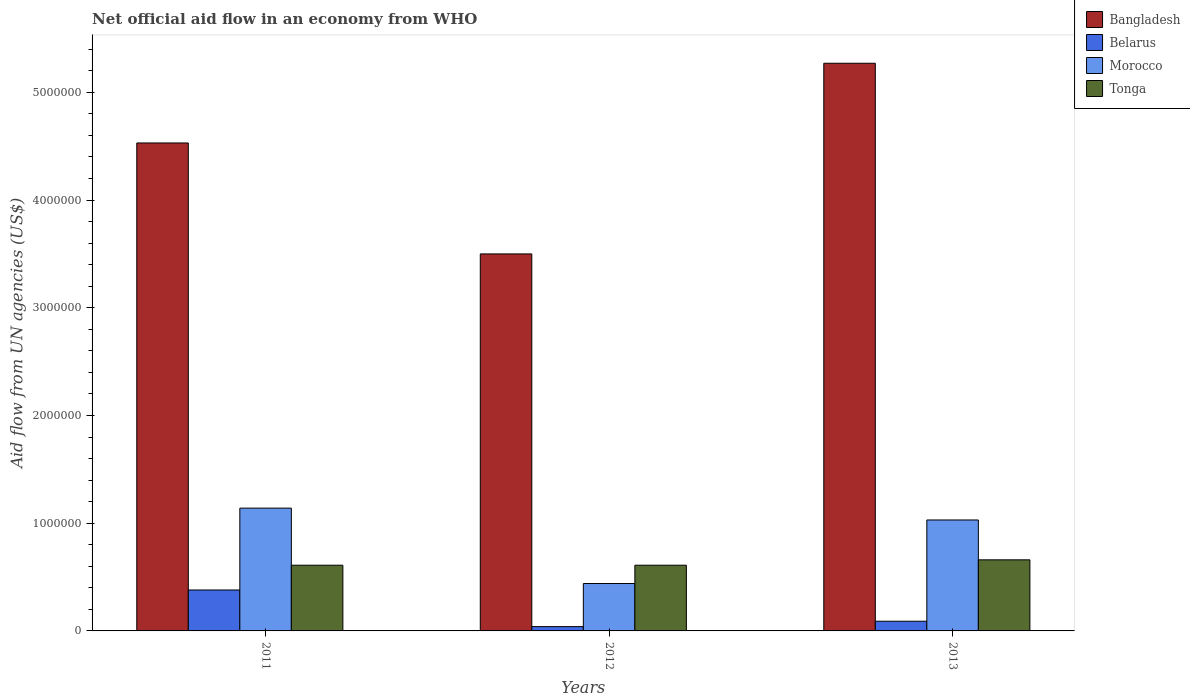Are the number of bars per tick equal to the number of legend labels?
Keep it short and to the point. Yes. How many bars are there on the 3rd tick from the left?
Your answer should be compact. 4. How many bars are there on the 2nd tick from the right?
Keep it short and to the point. 4. What is the net official aid flow in Bangladesh in 2013?
Give a very brief answer. 5.27e+06. Across all years, what is the maximum net official aid flow in Tonga?
Keep it short and to the point. 6.60e+05. What is the total net official aid flow in Bangladesh in the graph?
Give a very brief answer. 1.33e+07. What is the difference between the net official aid flow in Bangladesh in 2011 and that in 2012?
Make the answer very short. 1.03e+06. What is the difference between the net official aid flow in Tonga in 2012 and the net official aid flow in Bangladesh in 2013?
Provide a succinct answer. -4.66e+06. What is the average net official aid flow in Bangladesh per year?
Offer a terse response. 4.43e+06. In the year 2012, what is the difference between the net official aid flow in Belarus and net official aid flow in Tonga?
Ensure brevity in your answer.  -5.70e+05. What is the ratio of the net official aid flow in Morocco in 2011 to that in 2013?
Offer a terse response. 1.11. In how many years, is the net official aid flow in Belarus greater than the average net official aid flow in Belarus taken over all years?
Your response must be concise. 1. What does the 1st bar from the left in 2011 represents?
Your answer should be very brief. Bangladesh. Are all the bars in the graph horizontal?
Your answer should be very brief. No. How many years are there in the graph?
Make the answer very short. 3. What is the difference between two consecutive major ticks on the Y-axis?
Make the answer very short. 1.00e+06. Are the values on the major ticks of Y-axis written in scientific E-notation?
Your response must be concise. No. Does the graph contain grids?
Offer a very short reply. No. Where does the legend appear in the graph?
Ensure brevity in your answer.  Top right. What is the title of the graph?
Provide a succinct answer. Net official aid flow in an economy from WHO. What is the label or title of the Y-axis?
Your answer should be very brief. Aid flow from UN agencies (US$). What is the Aid flow from UN agencies (US$) of Bangladesh in 2011?
Ensure brevity in your answer.  4.53e+06. What is the Aid flow from UN agencies (US$) in Belarus in 2011?
Offer a terse response. 3.80e+05. What is the Aid flow from UN agencies (US$) of Morocco in 2011?
Give a very brief answer. 1.14e+06. What is the Aid flow from UN agencies (US$) in Bangladesh in 2012?
Your answer should be very brief. 3.50e+06. What is the Aid flow from UN agencies (US$) in Tonga in 2012?
Provide a succinct answer. 6.10e+05. What is the Aid flow from UN agencies (US$) of Bangladesh in 2013?
Give a very brief answer. 5.27e+06. What is the Aid flow from UN agencies (US$) of Belarus in 2013?
Keep it short and to the point. 9.00e+04. What is the Aid flow from UN agencies (US$) in Morocco in 2013?
Your answer should be very brief. 1.03e+06. What is the Aid flow from UN agencies (US$) of Tonga in 2013?
Your response must be concise. 6.60e+05. Across all years, what is the maximum Aid flow from UN agencies (US$) of Bangladesh?
Provide a short and direct response. 5.27e+06. Across all years, what is the maximum Aid flow from UN agencies (US$) of Belarus?
Keep it short and to the point. 3.80e+05. Across all years, what is the maximum Aid flow from UN agencies (US$) of Morocco?
Provide a succinct answer. 1.14e+06. Across all years, what is the maximum Aid flow from UN agencies (US$) of Tonga?
Provide a succinct answer. 6.60e+05. Across all years, what is the minimum Aid flow from UN agencies (US$) of Bangladesh?
Your answer should be compact. 3.50e+06. Across all years, what is the minimum Aid flow from UN agencies (US$) in Belarus?
Your answer should be very brief. 4.00e+04. Across all years, what is the minimum Aid flow from UN agencies (US$) in Morocco?
Offer a very short reply. 4.40e+05. What is the total Aid flow from UN agencies (US$) in Bangladesh in the graph?
Your response must be concise. 1.33e+07. What is the total Aid flow from UN agencies (US$) in Belarus in the graph?
Make the answer very short. 5.10e+05. What is the total Aid flow from UN agencies (US$) in Morocco in the graph?
Your response must be concise. 2.61e+06. What is the total Aid flow from UN agencies (US$) in Tonga in the graph?
Your response must be concise. 1.88e+06. What is the difference between the Aid flow from UN agencies (US$) of Bangladesh in 2011 and that in 2012?
Keep it short and to the point. 1.03e+06. What is the difference between the Aid flow from UN agencies (US$) of Morocco in 2011 and that in 2012?
Provide a succinct answer. 7.00e+05. What is the difference between the Aid flow from UN agencies (US$) of Tonga in 2011 and that in 2012?
Provide a short and direct response. 0. What is the difference between the Aid flow from UN agencies (US$) of Bangladesh in 2011 and that in 2013?
Offer a very short reply. -7.40e+05. What is the difference between the Aid flow from UN agencies (US$) of Tonga in 2011 and that in 2013?
Your answer should be compact. -5.00e+04. What is the difference between the Aid flow from UN agencies (US$) of Bangladesh in 2012 and that in 2013?
Offer a very short reply. -1.77e+06. What is the difference between the Aid flow from UN agencies (US$) of Morocco in 2012 and that in 2013?
Your answer should be very brief. -5.90e+05. What is the difference between the Aid flow from UN agencies (US$) in Tonga in 2012 and that in 2013?
Offer a very short reply. -5.00e+04. What is the difference between the Aid flow from UN agencies (US$) of Bangladesh in 2011 and the Aid flow from UN agencies (US$) of Belarus in 2012?
Provide a short and direct response. 4.49e+06. What is the difference between the Aid flow from UN agencies (US$) in Bangladesh in 2011 and the Aid flow from UN agencies (US$) in Morocco in 2012?
Offer a terse response. 4.09e+06. What is the difference between the Aid flow from UN agencies (US$) in Bangladesh in 2011 and the Aid flow from UN agencies (US$) in Tonga in 2012?
Give a very brief answer. 3.92e+06. What is the difference between the Aid flow from UN agencies (US$) in Morocco in 2011 and the Aid flow from UN agencies (US$) in Tonga in 2012?
Ensure brevity in your answer.  5.30e+05. What is the difference between the Aid flow from UN agencies (US$) of Bangladesh in 2011 and the Aid flow from UN agencies (US$) of Belarus in 2013?
Ensure brevity in your answer.  4.44e+06. What is the difference between the Aid flow from UN agencies (US$) of Bangladesh in 2011 and the Aid flow from UN agencies (US$) of Morocco in 2013?
Your answer should be very brief. 3.50e+06. What is the difference between the Aid flow from UN agencies (US$) in Bangladesh in 2011 and the Aid flow from UN agencies (US$) in Tonga in 2013?
Ensure brevity in your answer.  3.87e+06. What is the difference between the Aid flow from UN agencies (US$) in Belarus in 2011 and the Aid flow from UN agencies (US$) in Morocco in 2013?
Your answer should be very brief. -6.50e+05. What is the difference between the Aid flow from UN agencies (US$) of Belarus in 2011 and the Aid flow from UN agencies (US$) of Tonga in 2013?
Provide a succinct answer. -2.80e+05. What is the difference between the Aid flow from UN agencies (US$) in Morocco in 2011 and the Aid flow from UN agencies (US$) in Tonga in 2013?
Offer a terse response. 4.80e+05. What is the difference between the Aid flow from UN agencies (US$) in Bangladesh in 2012 and the Aid flow from UN agencies (US$) in Belarus in 2013?
Provide a succinct answer. 3.41e+06. What is the difference between the Aid flow from UN agencies (US$) of Bangladesh in 2012 and the Aid flow from UN agencies (US$) of Morocco in 2013?
Your answer should be very brief. 2.47e+06. What is the difference between the Aid flow from UN agencies (US$) in Bangladesh in 2012 and the Aid flow from UN agencies (US$) in Tonga in 2013?
Ensure brevity in your answer.  2.84e+06. What is the difference between the Aid flow from UN agencies (US$) of Belarus in 2012 and the Aid flow from UN agencies (US$) of Morocco in 2013?
Give a very brief answer. -9.90e+05. What is the difference between the Aid flow from UN agencies (US$) in Belarus in 2012 and the Aid flow from UN agencies (US$) in Tonga in 2013?
Provide a short and direct response. -6.20e+05. What is the average Aid flow from UN agencies (US$) of Bangladesh per year?
Your answer should be very brief. 4.43e+06. What is the average Aid flow from UN agencies (US$) in Belarus per year?
Make the answer very short. 1.70e+05. What is the average Aid flow from UN agencies (US$) of Morocco per year?
Keep it short and to the point. 8.70e+05. What is the average Aid flow from UN agencies (US$) in Tonga per year?
Your answer should be compact. 6.27e+05. In the year 2011, what is the difference between the Aid flow from UN agencies (US$) in Bangladesh and Aid flow from UN agencies (US$) in Belarus?
Your answer should be very brief. 4.15e+06. In the year 2011, what is the difference between the Aid flow from UN agencies (US$) in Bangladesh and Aid flow from UN agencies (US$) in Morocco?
Ensure brevity in your answer.  3.39e+06. In the year 2011, what is the difference between the Aid flow from UN agencies (US$) of Bangladesh and Aid flow from UN agencies (US$) of Tonga?
Ensure brevity in your answer.  3.92e+06. In the year 2011, what is the difference between the Aid flow from UN agencies (US$) of Belarus and Aid flow from UN agencies (US$) of Morocco?
Your answer should be compact. -7.60e+05. In the year 2011, what is the difference between the Aid flow from UN agencies (US$) of Morocco and Aid flow from UN agencies (US$) of Tonga?
Your answer should be very brief. 5.30e+05. In the year 2012, what is the difference between the Aid flow from UN agencies (US$) of Bangladesh and Aid flow from UN agencies (US$) of Belarus?
Give a very brief answer. 3.46e+06. In the year 2012, what is the difference between the Aid flow from UN agencies (US$) in Bangladesh and Aid flow from UN agencies (US$) in Morocco?
Make the answer very short. 3.06e+06. In the year 2012, what is the difference between the Aid flow from UN agencies (US$) of Bangladesh and Aid flow from UN agencies (US$) of Tonga?
Keep it short and to the point. 2.89e+06. In the year 2012, what is the difference between the Aid flow from UN agencies (US$) in Belarus and Aid flow from UN agencies (US$) in Morocco?
Offer a very short reply. -4.00e+05. In the year 2012, what is the difference between the Aid flow from UN agencies (US$) of Belarus and Aid flow from UN agencies (US$) of Tonga?
Your response must be concise. -5.70e+05. In the year 2012, what is the difference between the Aid flow from UN agencies (US$) in Morocco and Aid flow from UN agencies (US$) in Tonga?
Offer a very short reply. -1.70e+05. In the year 2013, what is the difference between the Aid flow from UN agencies (US$) in Bangladesh and Aid flow from UN agencies (US$) in Belarus?
Provide a short and direct response. 5.18e+06. In the year 2013, what is the difference between the Aid flow from UN agencies (US$) in Bangladesh and Aid flow from UN agencies (US$) in Morocco?
Provide a succinct answer. 4.24e+06. In the year 2013, what is the difference between the Aid flow from UN agencies (US$) of Bangladesh and Aid flow from UN agencies (US$) of Tonga?
Ensure brevity in your answer.  4.61e+06. In the year 2013, what is the difference between the Aid flow from UN agencies (US$) in Belarus and Aid flow from UN agencies (US$) in Morocco?
Offer a very short reply. -9.40e+05. In the year 2013, what is the difference between the Aid flow from UN agencies (US$) of Belarus and Aid flow from UN agencies (US$) of Tonga?
Offer a terse response. -5.70e+05. In the year 2013, what is the difference between the Aid flow from UN agencies (US$) in Morocco and Aid flow from UN agencies (US$) in Tonga?
Your answer should be very brief. 3.70e+05. What is the ratio of the Aid flow from UN agencies (US$) of Bangladesh in 2011 to that in 2012?
Ensure brevity in your answer.  1.29. What is the ratio of the Aid flow from UN agencies (US$) of Belarus in 2011 to that in 2012?
Provide a short and direct response. 9.5. What is the ratio of the Aid flow from UN agencies (US$) of Morocco in 2011 to that in 2012?
Provide a succinct answer. 2.59. What is the ratio of the Aid flow from UN agencies (US$) of Tonga in 2011 to that in 2012?
Provide a short and direct response. 1. What is the ratio of the Aid flow from UN agencies (US$) in Bangladesh in 2011 to that in 2013?
Your response must be concise. 0.86. What is the ratio of the Aid flow from UN agencies (US$) in Belarus in 2011 to that in 2013?
Your answer should be very brief. 4.22. What is the ratio of the Aid flow from UN agencies (US$) in Morocco in 2011 to that in 2013?
Keep it short and to the point. 1.11. What is the ratio of the Aid flow from UN agencies (US$) in Tonga in 2011 to that in 2013?
Your response must be concise. 0.92. What is the ratio of the Aid flow from UN agencies (US$) of Bangladesh in 2012 to that in 2013?
Offer a terse response. 0.66. What is the ratio of the Aid flow from UN agencies (US$) of Belarus in 2012 to that in 2013?
Provide a short and direct response. 0.44. What is the ratio of the Aid flow from UN agencies (US$) in Morocco in 2012 to that in 2013?
Provide a succinct answer. 0.43. What is the ratio of the Aid flow from UN agencies (US$) of Tonga in 2012 to that in 2013?
Make the answer very short. 0.92. What is the difference between the highest and the second highest Aid flow from UN agencies (US$) of Bangladesh?
Give a very brief answer. 7.40e+05. What is the difference between the highest and the second highest Aid flow from UN agencies (US$) in Tonga?
Provide a short and direct response. 5.00e+04. What is the difference between the highest and the lowest Aid flow from UN agencies (US$) of Bangladesh?
Offer a terse response. 1.77e+06. What is the difference between the highest and the lowest Aid flow from UN agencies (US$) in Morocco?
Offer a terse response. 7.00e+05. 